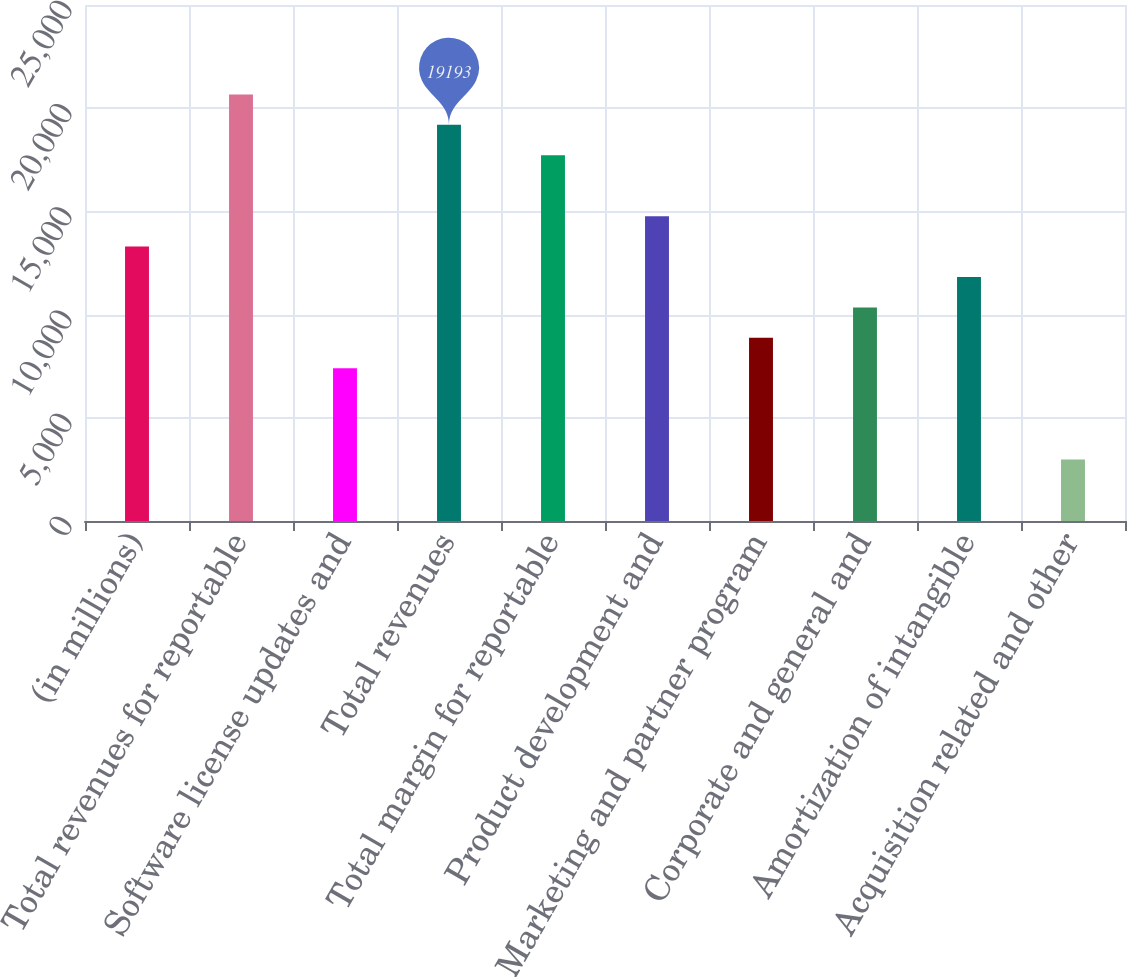Convert chart. <chart><loc_0><loc_0><loc_500><loc_500><bar_chart><fcel>(in millions)<fcel>Total revenues for reportable<fcel>Software license updates and<fcel>Total revenues<fcel>Total margin for reportable<fcel>Product development and<fcel>Marketing and partner program<fcel>Corporate and general and<fcel>Amortization of intangible<fcel>Acquisition related and other<nl><fcel>13297<fcel>20667<fcel>7401<fcel>19193<fcel>17719<fcel>14771<fcel>8875<fcel>10349<fcel>11823<fcel>2979<nl></chart> 